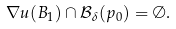<formula> <loc_0><loc_0><loc_500><loc_500>\nabla u ( B _ { 1 } ) \cap \mathcal { B } _ { \delta } ( p _ { 0 } ) = \emptyset .</formula> 